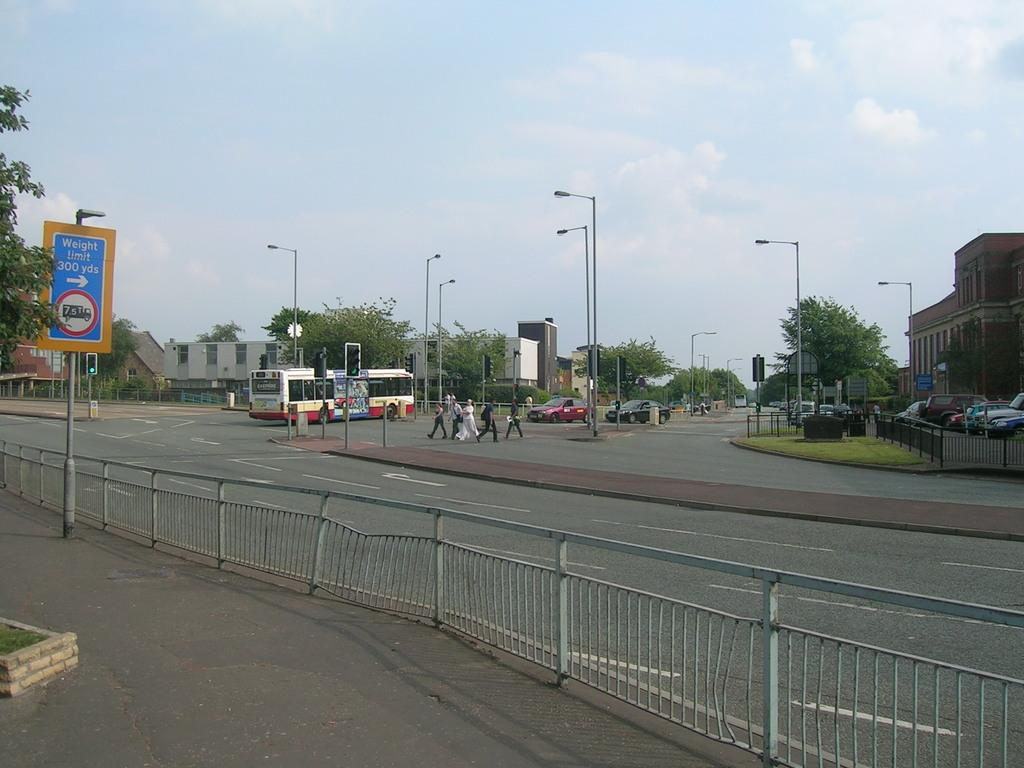Provide a one-sentence caption for the provided image. A road sign cautions of a weight limit in effect 300 yards away. 